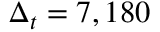<formula> <loc_0><loc_0><loc_500><loc_500>\Delta _ { t } = 7 , 1 8 0</formula> 